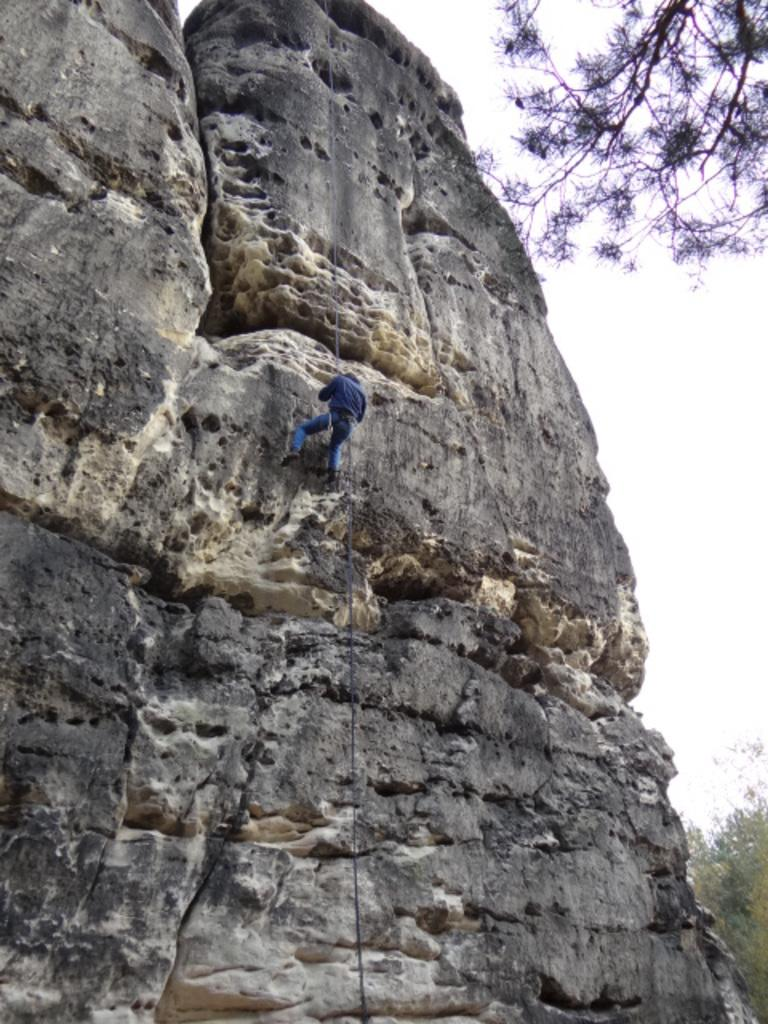What is present in the image? There is a person in the image. Can you describe the person's clothing? The person is wearing a blue dress. What can be seen in the background of the image? There are rocks, green trees, and the sky visible in the background of the image. What is the color of the sky in the image? The sky appears to be white in color. Can you see a giraffe in the image? No, there is no giraffe present in the image. Is the person wearing a coat in the image? No, the person is wearing a blue dress, not a coat. 